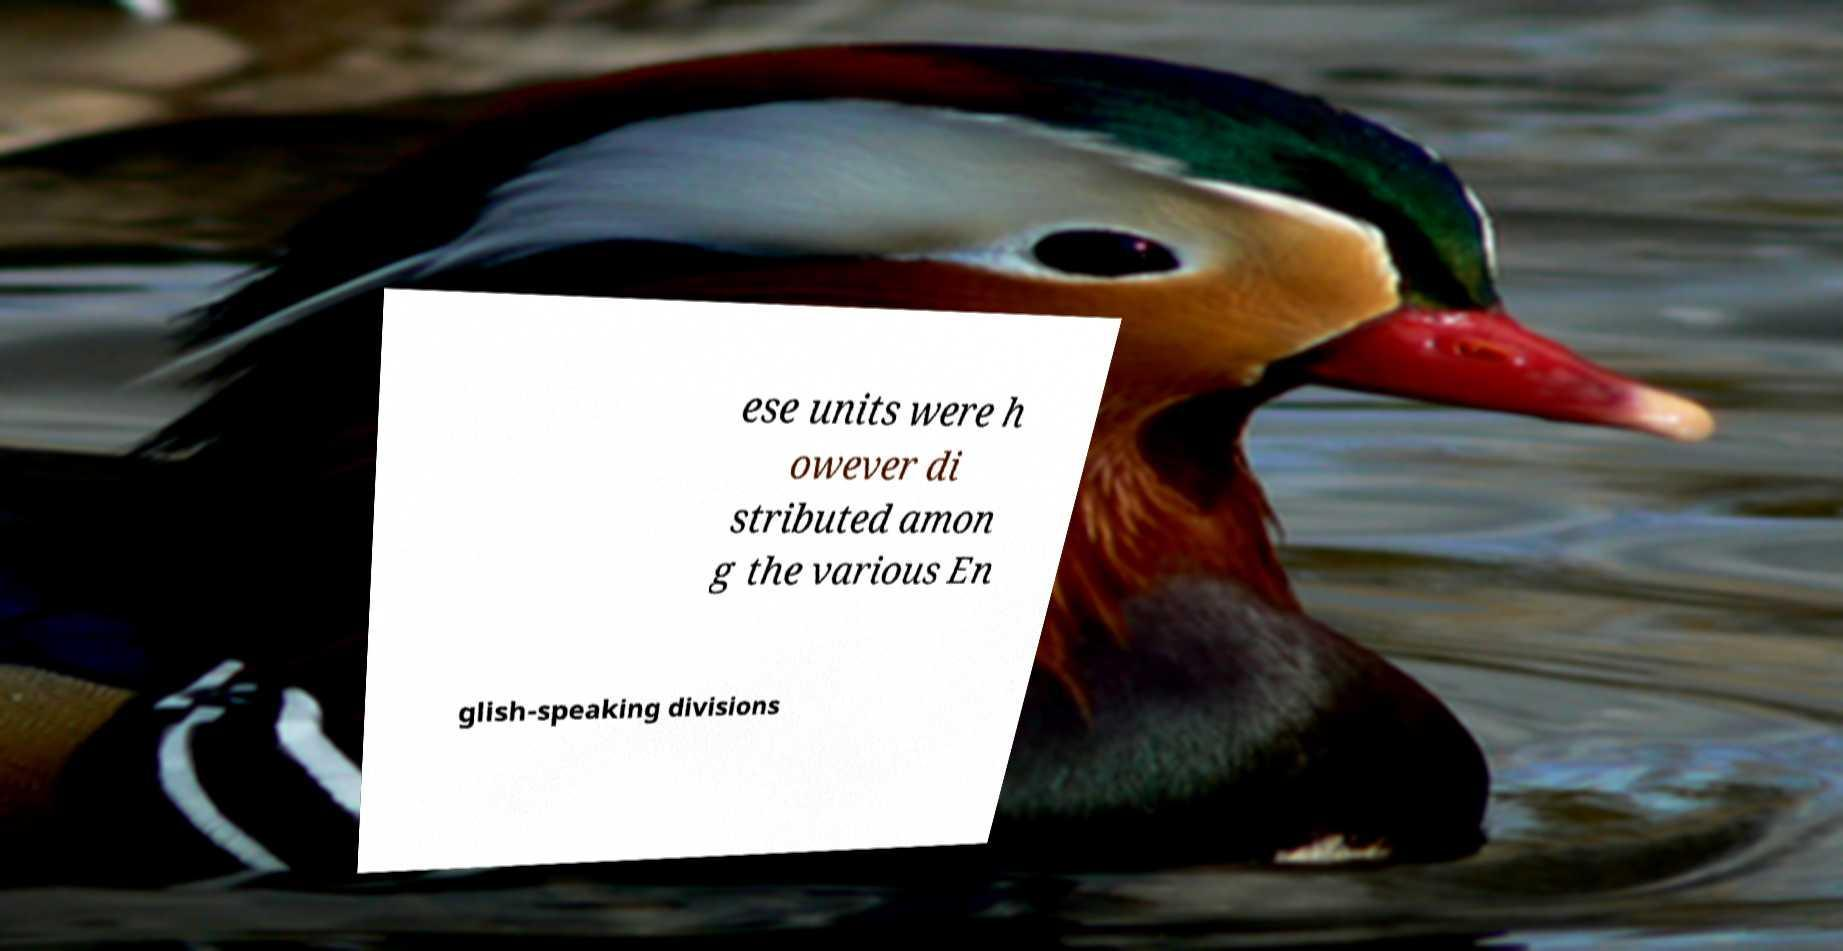Please read and relay the text visible in this image. What does it say? ese units were h owever di stributed amon g the various En glish-speaking divisions 